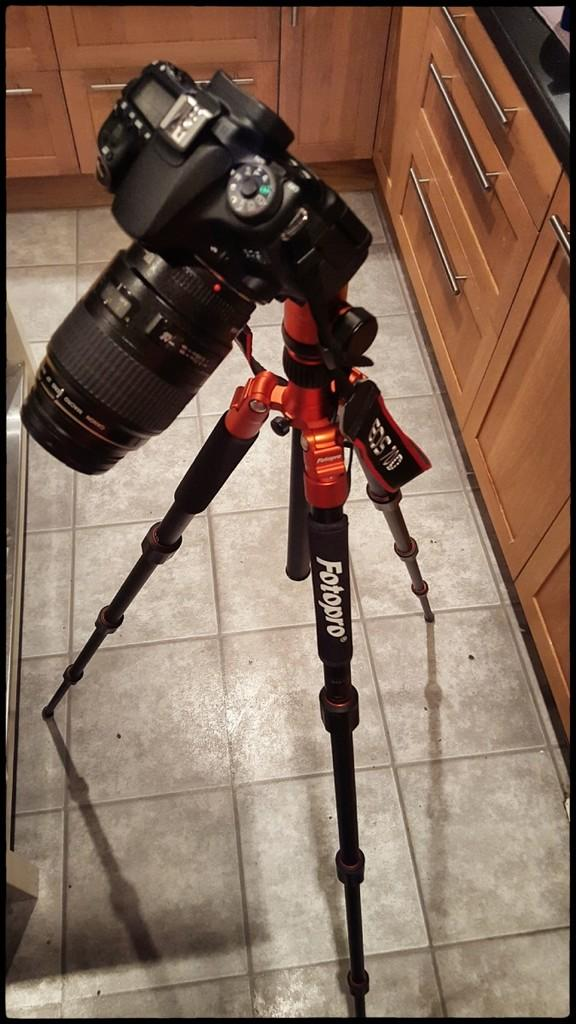What is the main object in the image? There is a camera in the image. What is supporting the camera? There is a stand in the image that supports the camera. What type of surface is visible in the image? There is a floor in the image. What type of furniture is present in the image? There are cupboards in the image. What type of rhythm does the camera follow in the image? The camera does not follow a rhythm in the image; it is stationary. What type of beast can be seen interacting with the camera in the image? There is no beast present in the image; it only features a camera, stand, floor, and cupboards. 